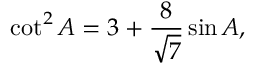Convert formula to latex. <formula><loc_0><loc_0><loc_500><loc_500>\cot ^ { 2 } A = 3 + { \frac { 8 } { \sqrt { 7 } } } \sin A ,</formula> 